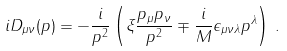<formula> <loc_0><loc_0><loc_500><loc_500>i D _ { \mu \nu } ( p ) = - \frac { i } { p ^ { 2 } } \left ( \xi \frac { p _ { \mu } p _ { \nu } } { p ^ { 2 } } \mp \frac { i } { M } \epsilon _ { \mu \nu \lambda } p ^ { \lambda } \right ) \, .</formula> 